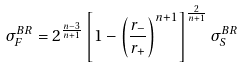Convert formula to latex. <formula><loc_0><loc_0><loc_500><loc_500>\sigma _ { F } ^ { B R } = 2 ^ { \frac { n - 3 } { n + 1 } } \left [ 1 - \left ( \frac { r _ { - } } { r _ { + } } \right ) ^ { n + 1 } \right ] ^ { \frac { 2 } { n + 1 } } \sigma _ { S } ^ { B R }</formula> 